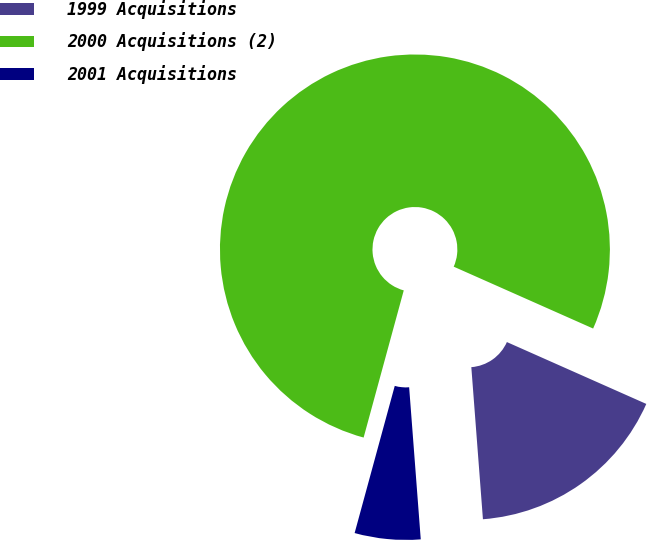<chart> <loc_0><loc_0><loc_500><loc_500><pie_chart><fcel>1999 Acquisitions<fcel>2000 Acquisitions (2)<fcel>2001 Acquisitions<nl><fcel>17.14%<fcel>77.41%<fcel>5.45%<nl></chart> 